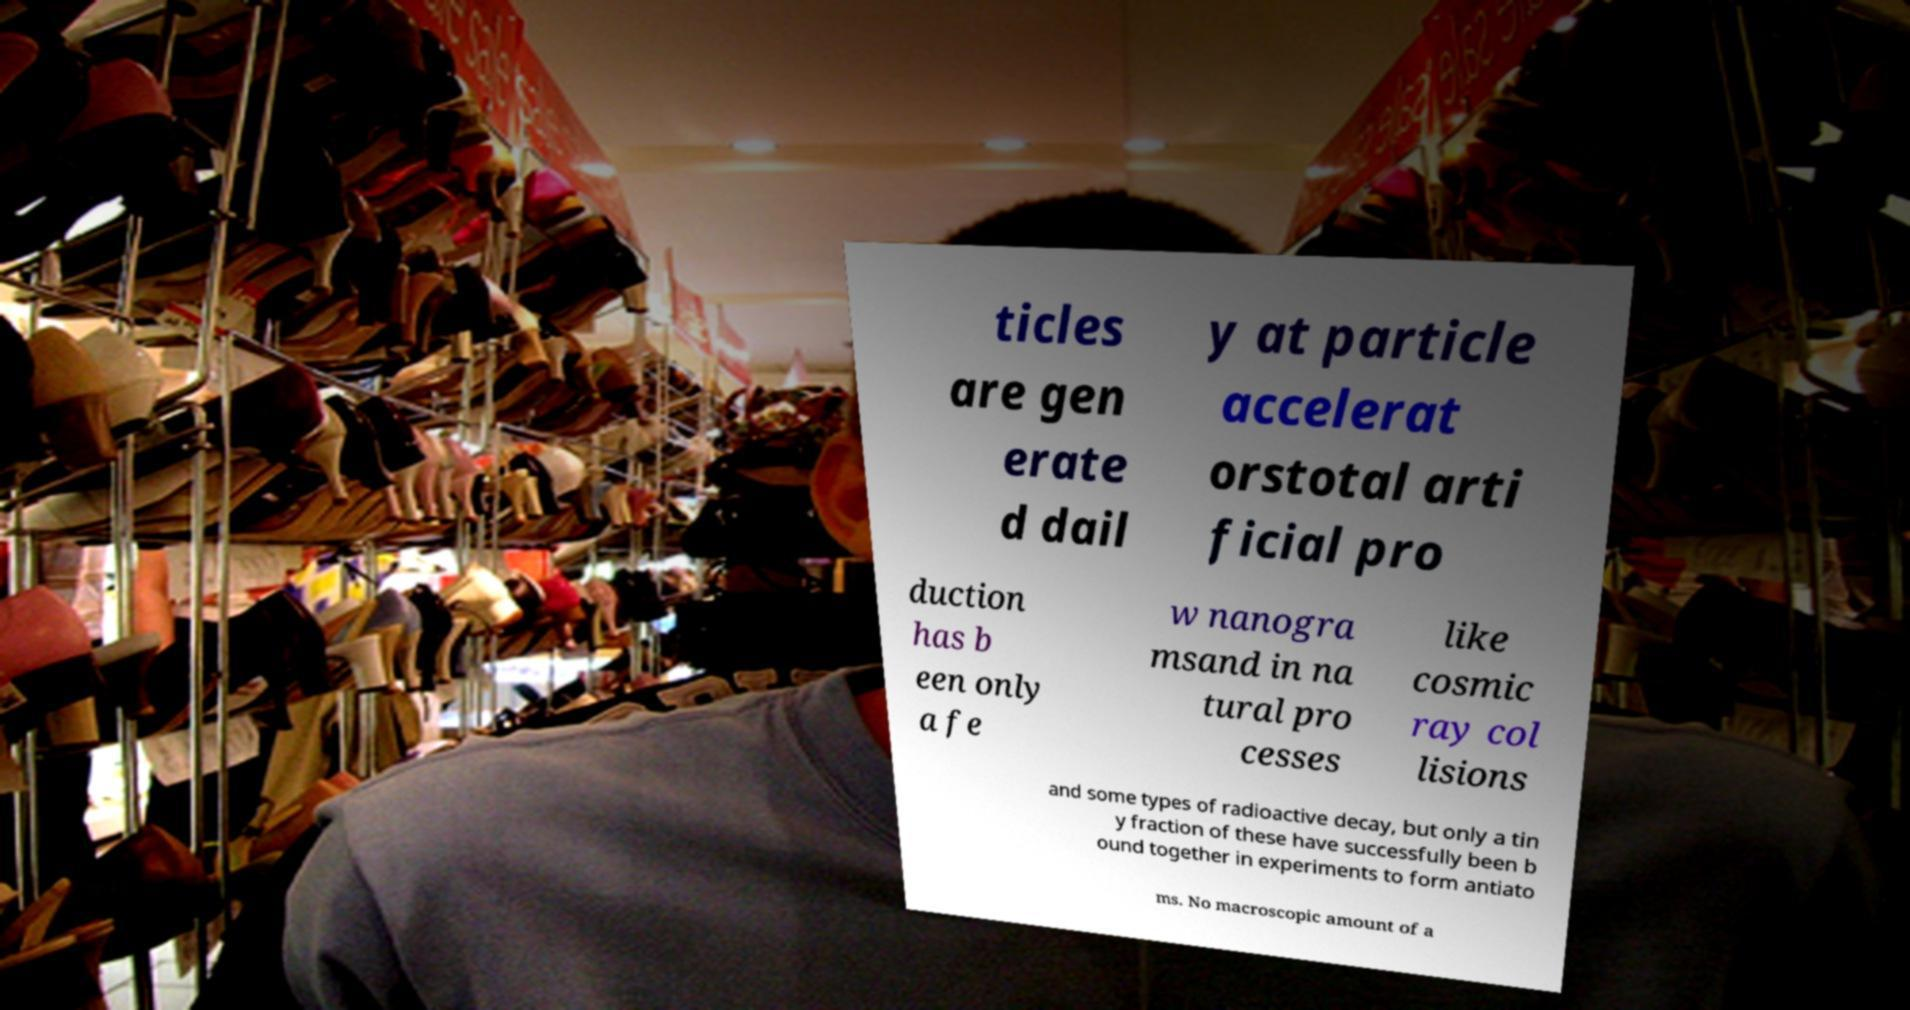Can you accurately transcribe the text from the provided image for me? ticles are gen erate d dail y at particle accelerat orstotal arti ficial pro duction has b een only a fe w nanogra msand in na tural pro cesses like cosmic ray col lisions and some types of radioactive decay, but only a tin y fraction of these have successfully been b ound together in experiments to form antiato ms. No macroscopic amount of a 